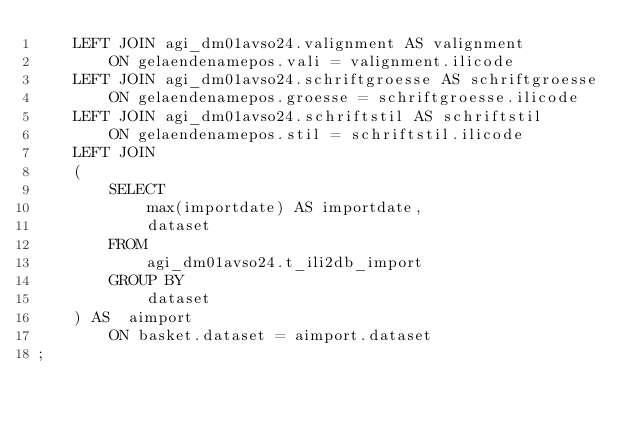Convert code to text. <code><loc_0><loc_0><loc_500><loc_500><_SQL_>    LEFT JOIN agi_dm01avso24.valignment AS valignment
        ON gelaendenamepos.vali = valignment.ilicode
    LEFT JOIN agi_dm01avso24.schriftgroesse AS schriftgroesse
        ON gelaendenamepos.groesse = schriftgroesse.ilicode
    LEFT JOIN agi_dm01avso24.schriftstil AS schriftstil
        ON gelaendenamepos.stil = schriftstil.ilicode
    LEFT JOIN 
    (
        SELECT
            max(importdate) AS importdate,
            dataset
        FROM
            agi_dm01avso24.t_ili2db_import
        GROUP BY
            dataset 
    ) AS  aimport
        ON basket.dataset = aimport.dataset
;
</code> 